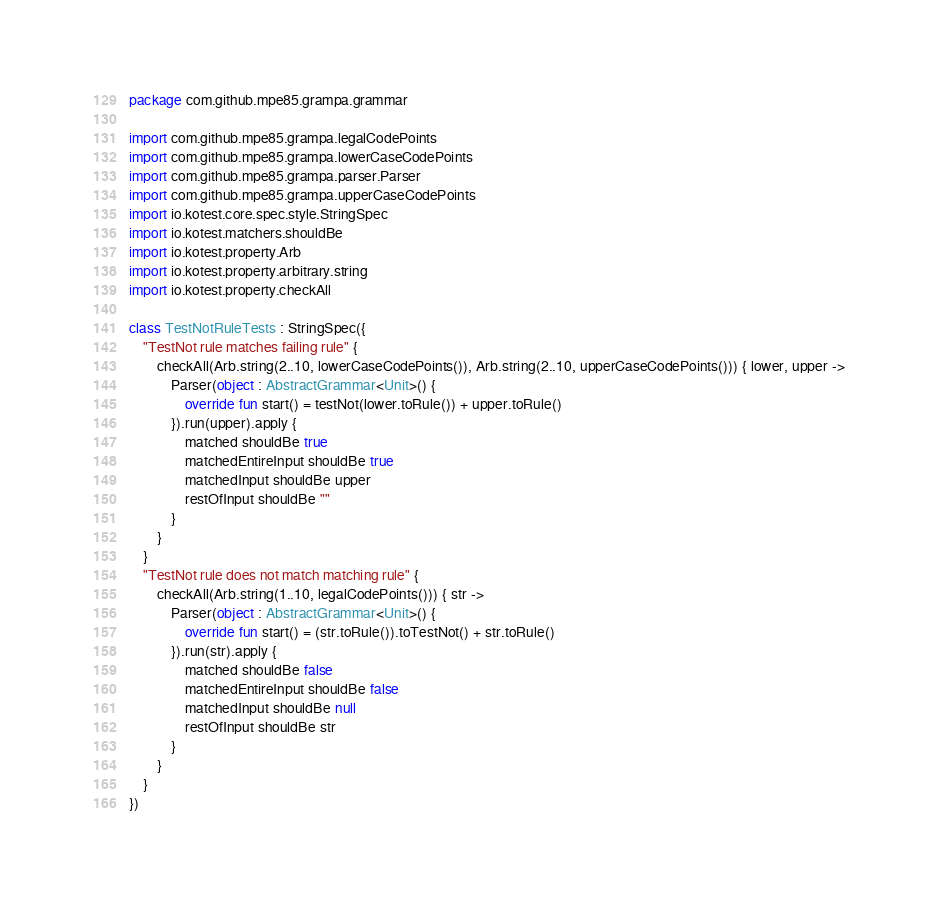<code> <loc_0><loc_0><loc_500><loc_500><_Kotlin_>package com.github.mpe85.grampa.grammar

import com.github.mpe85.grampa.legalCodePoints
import com.github.mpe85.grampa.lowerCaseCodePoints
import com.github.mpe85.grampa.parser.Parser
import com.github.mpe85.grampa.upperCaseCodePoints
import io.kotest.core.spec.style.StringSpec
import io.kotest.matchers.shouldBe
import io.kotest.property.Arb
import io.kotest.property.arbitrary.string
import io.kotest.property.checkAll

class TestNotRuleTests : StringSpec({
    "TestNot rule matches failing rule" {
        checkAll(Arb.string(2..10, lowerCaseCodePoints()), Arb.string(2..10, upperCaseCodePoints())) { lower, upper ->
            Parser(object : AbstractGrammar<Unit>() {
                override fun start() = testNot(lower.toRule()) + upper.toRule()
            }).run(upper).apply {
                matched shouldBe true
                matchedEntireInput shouldBe true
                matchedInput shouldBe upper
                restOfInput shouldBe ""
            }
        }
    }
    "TestNot rule does not match matching rule" {
        checkAll(Arb.string(1..10, legalCodePoints())) { str ->
            Parser(object : AbstractGrammar<Unit>() {
                override fun start() = (str.toRule()).toTestNot() + str.toRule()
            }).run(str).apply {
                matched shouldBe false
                matchedEntireInput shouldBe false
                matchedInput shouldBe null
                restOfInput shouldBe str
            }
        }
    }
})
</code> 